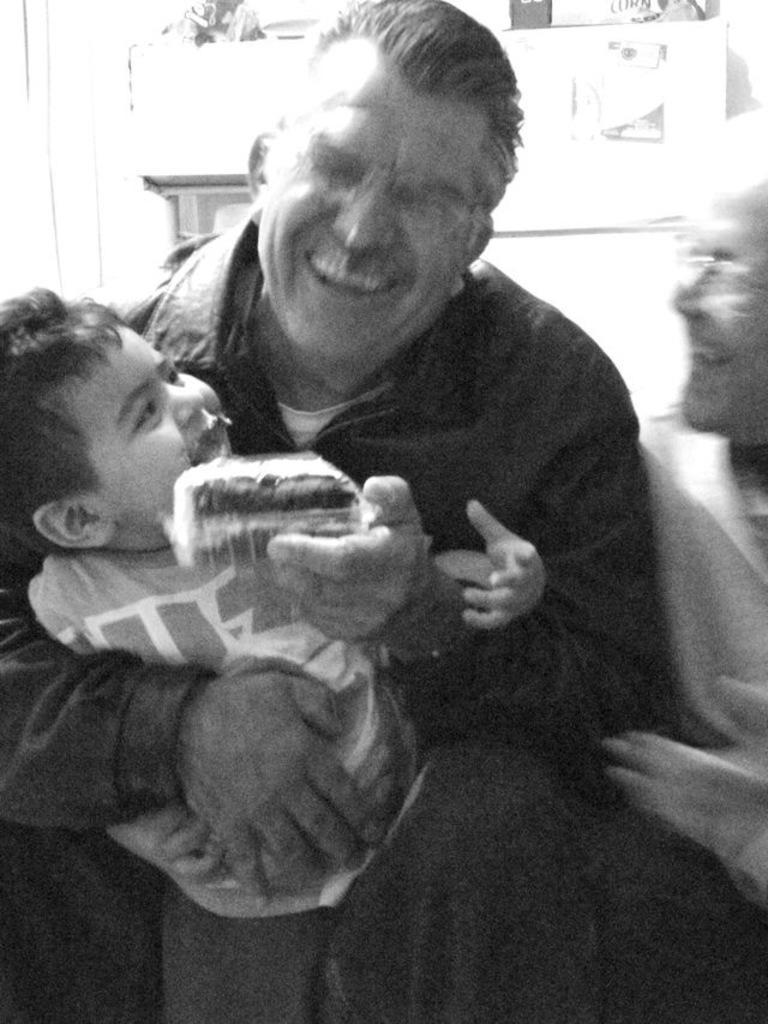Please provide a concise description of this image. In this picture we can observe three members. Two of them are adults and the other is a kid. All of them are smiling. This is a black and white image. 